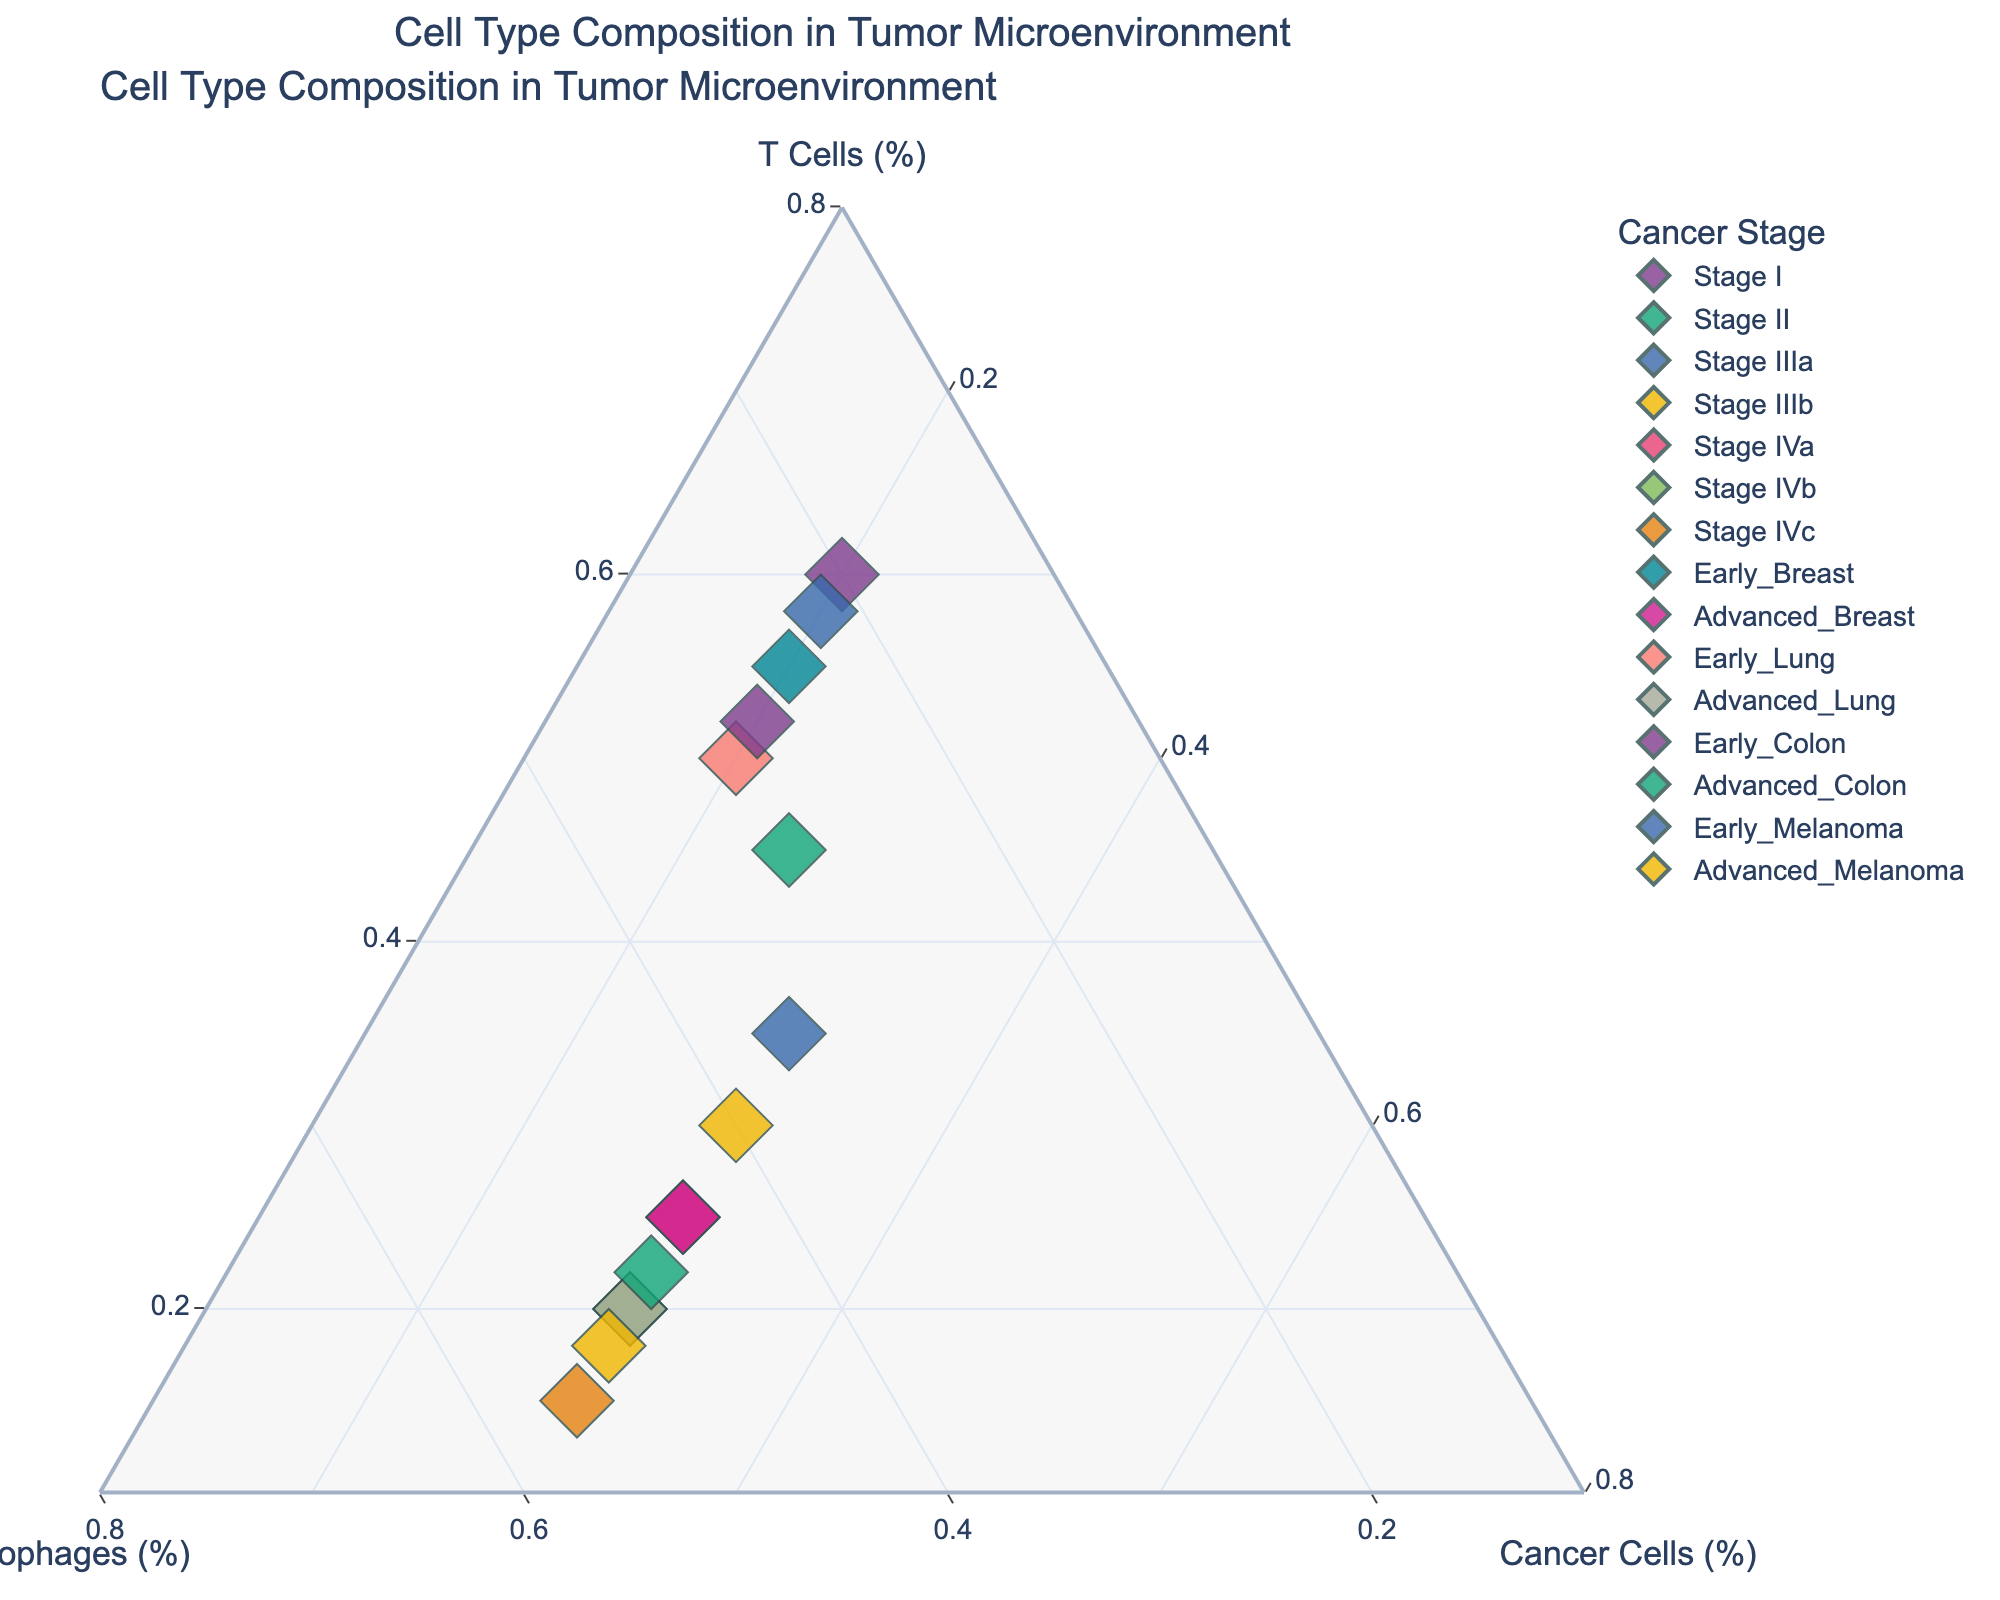What is the title of the figure? The title is usually displayed at the top of the figure.
Answer: Cell Type Composition in Tumor Microenvironment Which cell type is most abundant in Stage I cancer? In Stage I, T Cells have a 60% composition, which is the highest among the three cell types.
Answer: T Cells How does the composition of T Cells change from Stage I to Stage IVc? In Stage I, T Cells make up 60%, and this percentage decreases progressively to 15% in Stage IVc.
Answer: Decreases Which two cancer stages have the highest percentage of Macrophages? By observing the percentages, Stage IVb and Stage IVc both have the highest Macrophages percentage at 50% and 55% respectively.
Answer: Stage IVb and Stage IVc Compare the composition of Cancer Cells in ‘Early_Breast’ and ‘Advanced_Breast’ stages. ‘Early_Breast’ has 20% Cancer Cells, while ‘Advanced_Breast’ has 30% Cancer Cells.
Answer: Higher in ‘Advanced_Breast’ Is there a stage where the T Cells and Macrophages have the same composition percentages? At Stage IIIa, both T Cells and Macrophages share the same percentage of 35%.
Answer: Stage IIIa What's the average percentage of T Cells across all early cancer stages (Early_Breast, Early_Lung, Early_Colon, Early_Melanoma)? The percentages are: 55 (Early_Breast) + 50 (Early_Lung) + 52 (Early_Colon) + 58 (Early_Melanoma). The sum is 215. The average is 215/4 = 53.75.
Answer: 53.75 Which early cancer stage has the lowest percentage of Macrophages? Among Early_Breast, Early_Lung, Early_Colon, and Early_Melanoma, Early_Melanoma has the lowest Macrophages percentage at 22%.
Answer: Early_Melanoma Is there a discernible pattern in the composition of Cancer Cells as cancer stage progresses from Stage I to Stage IVc? Cancer Cells composition remains constant at 20% in Stage I, and increases to 30% by Stage IVa, where it levels off through to Stage IVc.
Answer: Increases then levels off If we combine both 'Advanced_Lung' and 'Advanced_Melanoma' stages, what is their average Macrophages percentage? Advanced_Lung (50%) + Advanced_Melanoma (52%), sum = 102. Average is 102/2 = 51.
Answer: 51 